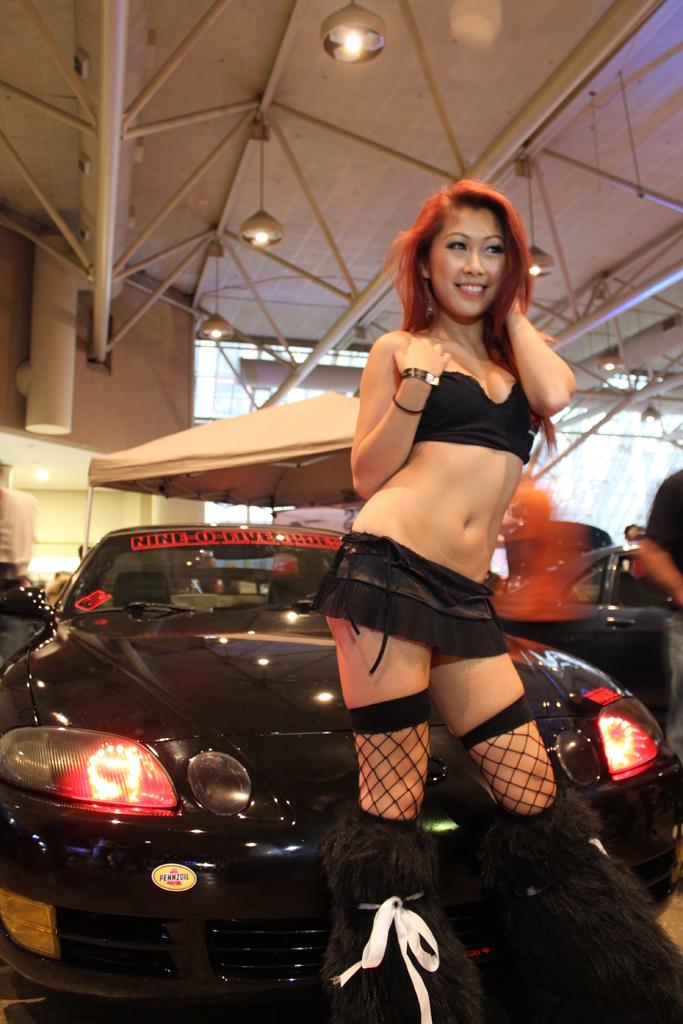What is the main subject of the image? There is a woman standing in the center of the image. What is the woman standing on? The woman is standing on the ground. What can be seen in the background of the image? There are cars, a tent, lights, a roof, and a wall in the background of the image. What type of ink is the woman using to write her name in the image? There is no indication in the image that the woman is writing her name or using any ink. 